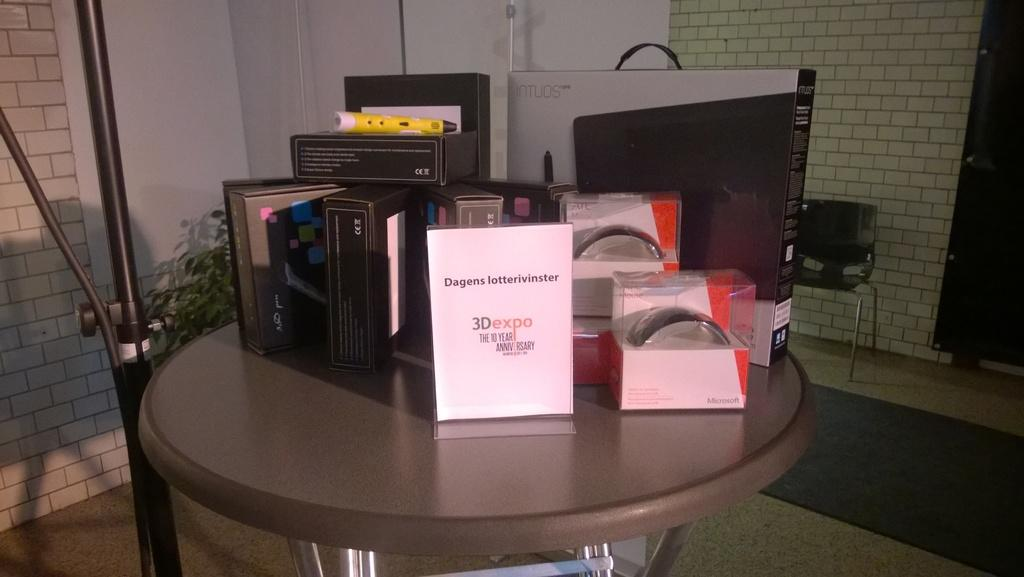<image>
Offer a succinct explanation of the picture presented. a 10 year anniversary special showcasing products for the 3D expo 